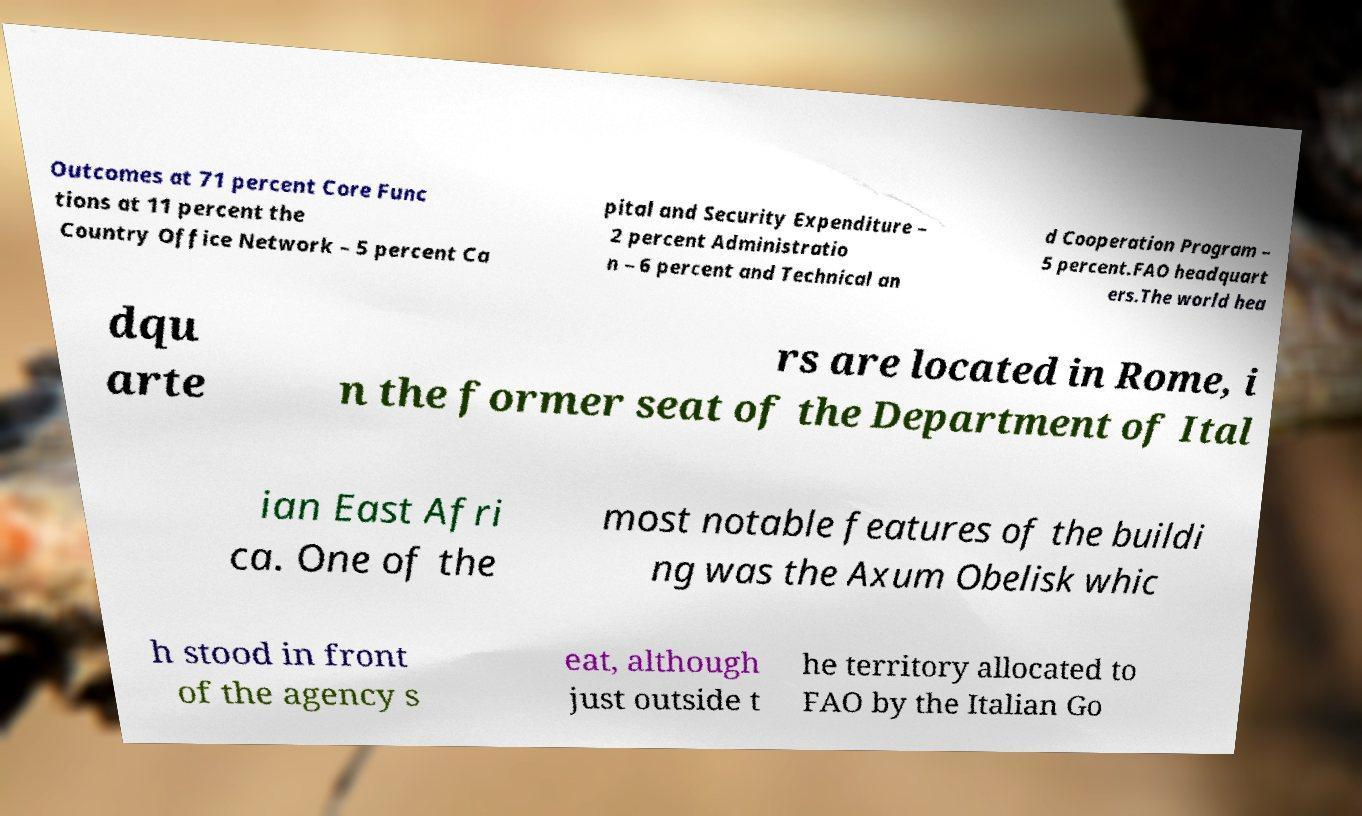Could you assist in decoding the text presented in this image and type it out clearly? Outcomes at 71 percent Core Func tions at 11 percent the Country Office Network – 5 percent Ca pital and Security Expenditure – 2 percent Administratio n – 6 percent and Technical an d Cooperation Program – 5 percent.FAO headquart ers.The world hea dqu arte rs are located in Rome, i n the former seat of the Department of Ital ian East Afri ca. One of the most notable features of the buildi ng was the Axum Obelisk whic h stood in front of the agency s eat, although just outside t he territory allocated to FAO by the Italian Go 